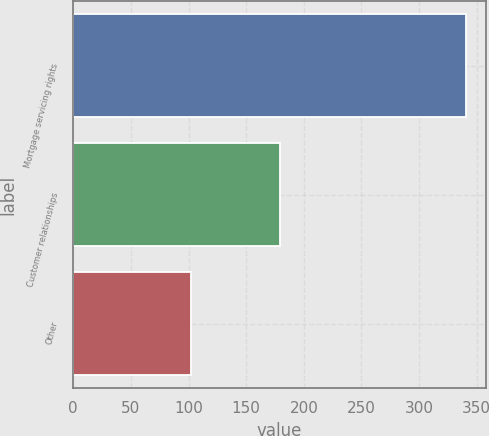Convert chart to OTSL. <chart><loc_0><loc_0><loc_500><loc_500><bar_chart><fcel>Mortgage servicing rights<fcel>Customer relationships<fcel>Other<nl><fcel>341<fcel>179<fcel>102<nl></chart> 